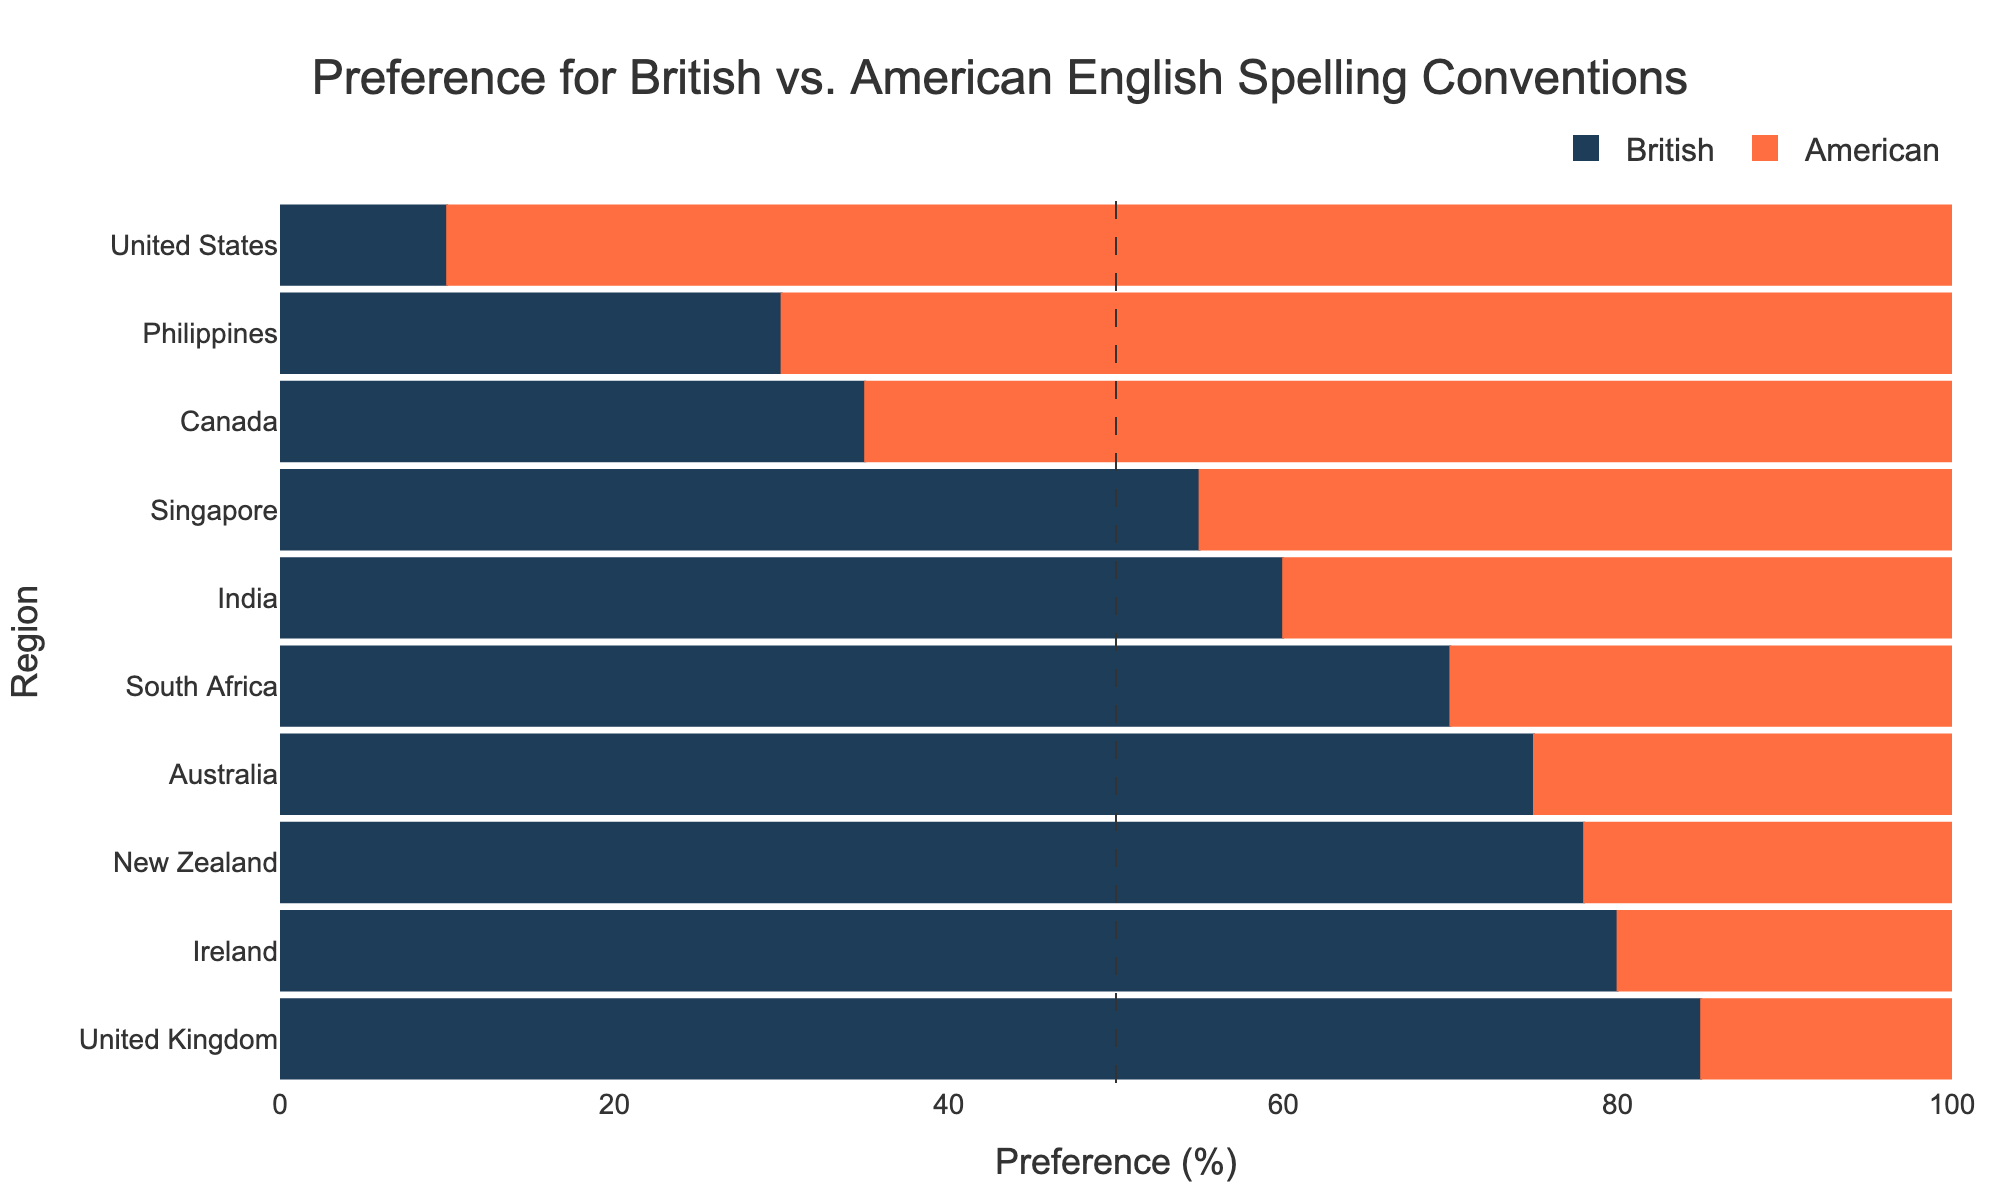What is the region with the highest preference for British spelling? To determine the highest preference for British spelling, look at the bar representing "Preference British" and find the longest bar. Compare the lengths to identify the region with the longest bar.
Answer: United Kingdom Which region has the largest difference in preference between British and American spellings, and what is the magnitude of that difference? To find the largest difference, calculate the absolute difference between "Preference British" and "Preference American" for each region. The region with the highest value is the one with the largest difference.
Answer: United Kingdom, 70 What is the sum of the preferences for British spelling in Canada and Ireland? Add the values for "Preference British" in Canada (35) and Ireland (80).
Answer: 115 Compare the preferences for American spelling in Singapore and the Philippines. Which region has a higher preference for American spelling and by how much? Compare the values for "Preference American" in Singapore (45) and the Philippines (70). Subtract the smaller value from the larger value to find the difference.
Answer: Philippines, 25 Which three regions have the closest preference values for British and American spellings? Calculate the absolute difference between "Preference British" and "Preference American" for each region. The three regions with the smallest differences are the ones with the closest preferences.
Answer: Singapore, India, Canada What is the average preference for British spelling across all regions? Sum the "Preference British" values for all regions and divide by the number of regions (10). The sum is (85 + 10 + 35 + 75 + 60 + 70 + 80 + 78 + 55 + 30) = 578. The average is 578/10.
Answer: 57.8 Based on the visual attributes of the bars, which regions have a stronger preference for American spelling than British spelling? Look for regions where the American spelling bar is longer than the British spelling bar. Compare their lengths visually.
Answer: United States, Canada, Philippines In how many regions is the preference for British spelling greater than 70%? Count the regions where the "Preference British" value is greater than 70.
Answer: 4 If we combined the preferences for British spelling in the United Kingdom and Australia, what would the total preference be? Add the "Preference British" values for the United Kingdom (85) and Australia (75).
Answer: 160 